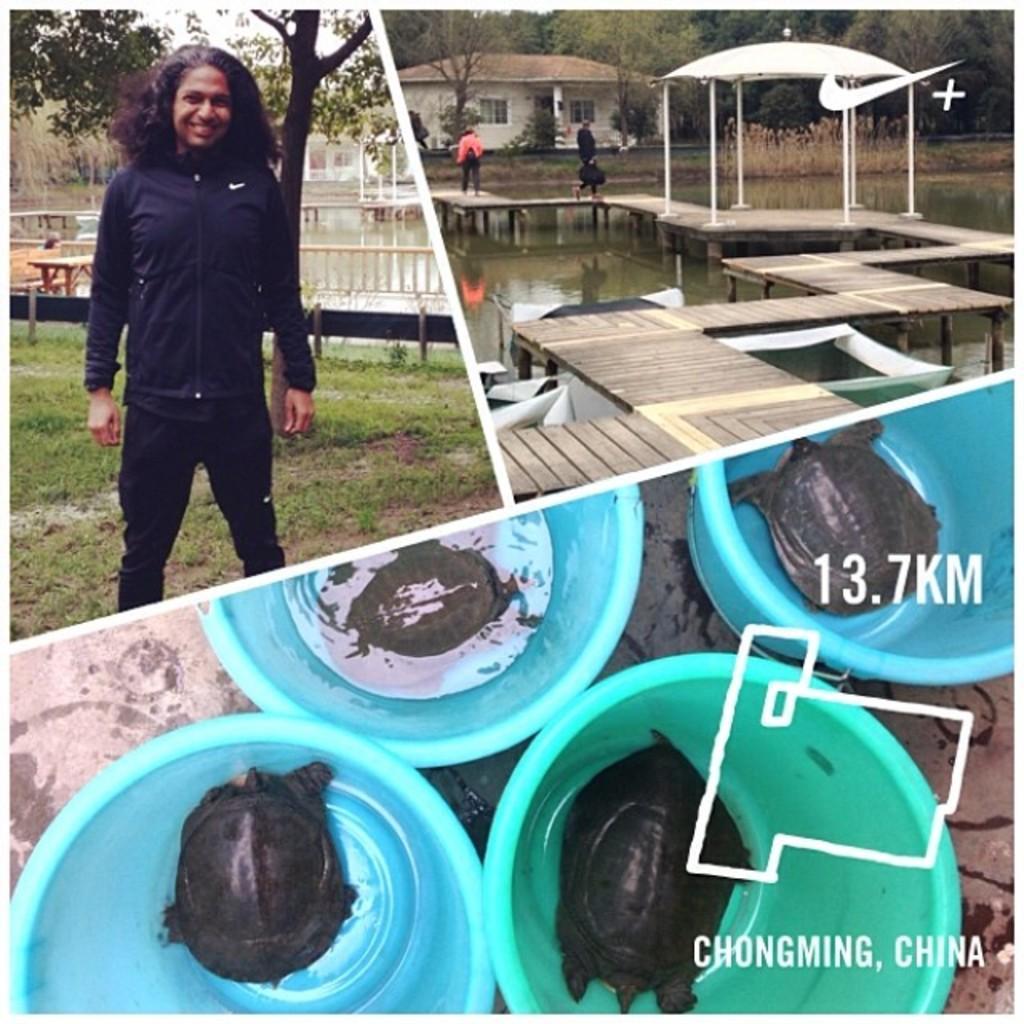Describe this image in one or two sentences. In this image we can see a collage of pictures. On the left side of the image we can see a person standing on the ground. In the foreground we can see group of animals placed in containers. In the background, we can see a deck on the water a building, group of trees, and a shed. 